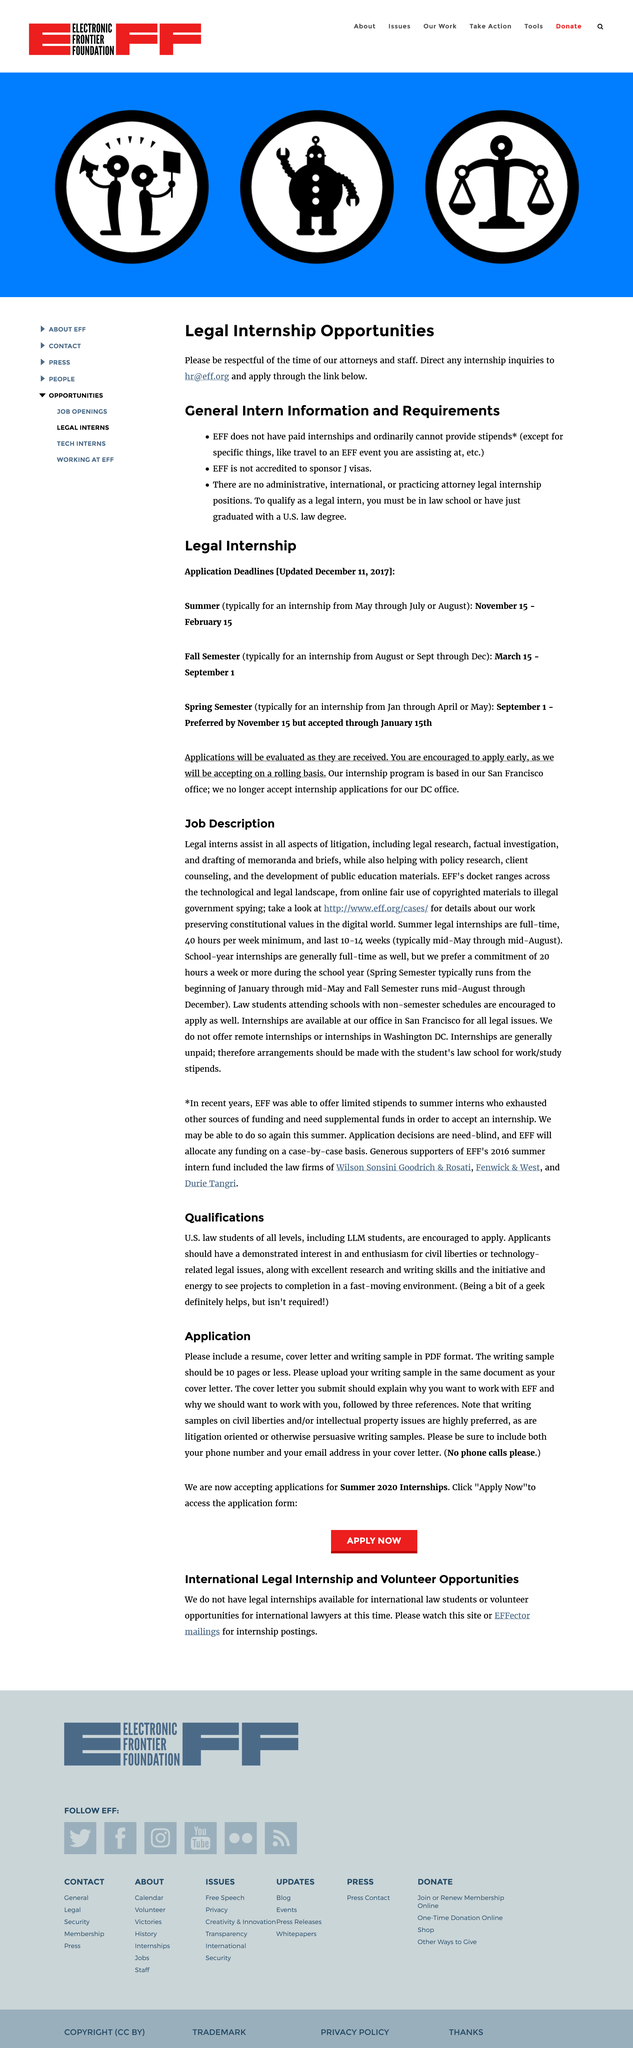Specify some key components in this picture. The fact that legal interns will be responsible for assisting in all aspects of litigation is indeed an aspect of their job description. EFF's docket range encompasses both the technological and legal landscape, spanning a wide range of issues related to digital rights and freedom. 